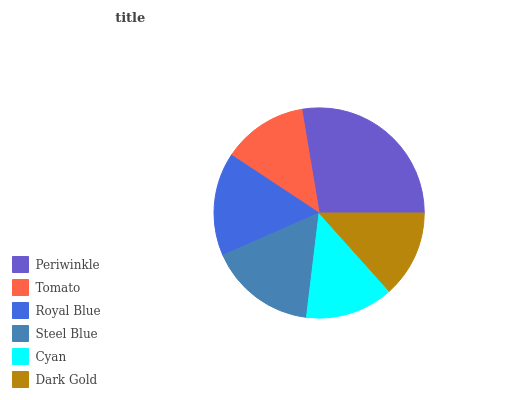Is Tomato the minimum?
Answer yes or no. Yes. Is Periwinkle the maximum?
Answer yes or no. Yes. Is Royal Blue the minimum?
Answer yes or no. No. Is Royal Blue the maximum?
Answer yes or no. No. Is Royal Blue greater than Tomato?
Answer yes or no. Yes. Is Tomato less than Royal Blue?
Answer yes or no. Yes. Is Tomato greater than Royal Blue?
Answer yes or no. No. Is Royal Blue less than Tomato?
Answer yes or no. No. Is Royal Blue the high median?
Answer yes or no. Yes. Is Cyan the low median?
Answer yes or no. Yes. Is Periwinkle the high median?
Answer yes or no. No. Is Royal Blue the low median?
Answer yes or no. No. 